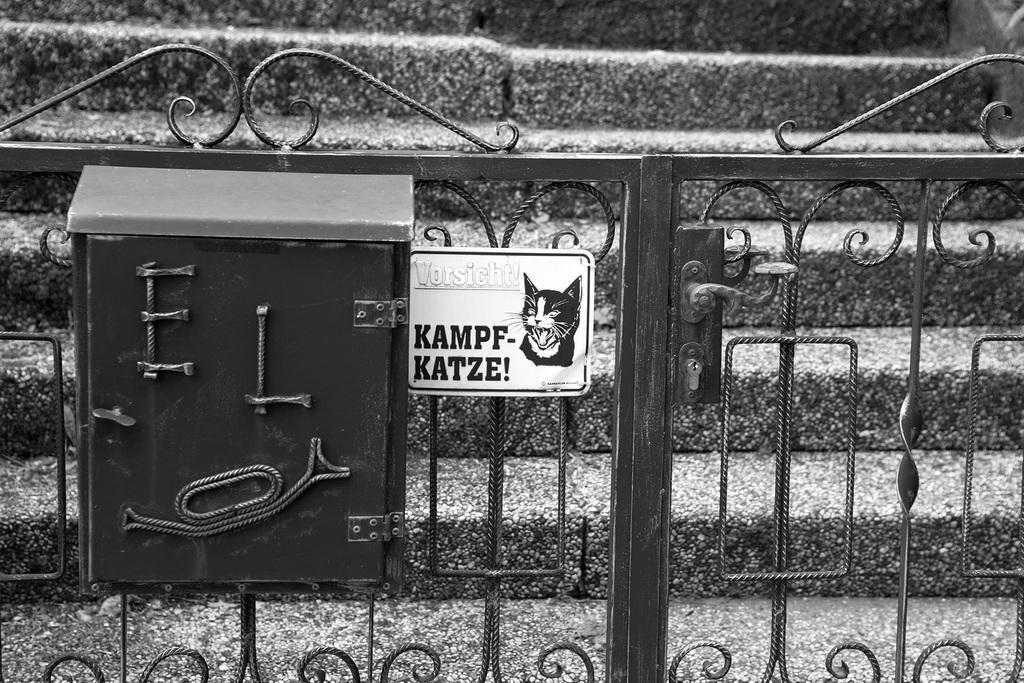In one or two sentences, can you explain what this image depicts? In this image there is a metal gate having a box and a board attached to it. On the board there is an image of a cat and some text. Behind the gate there are stairs. 